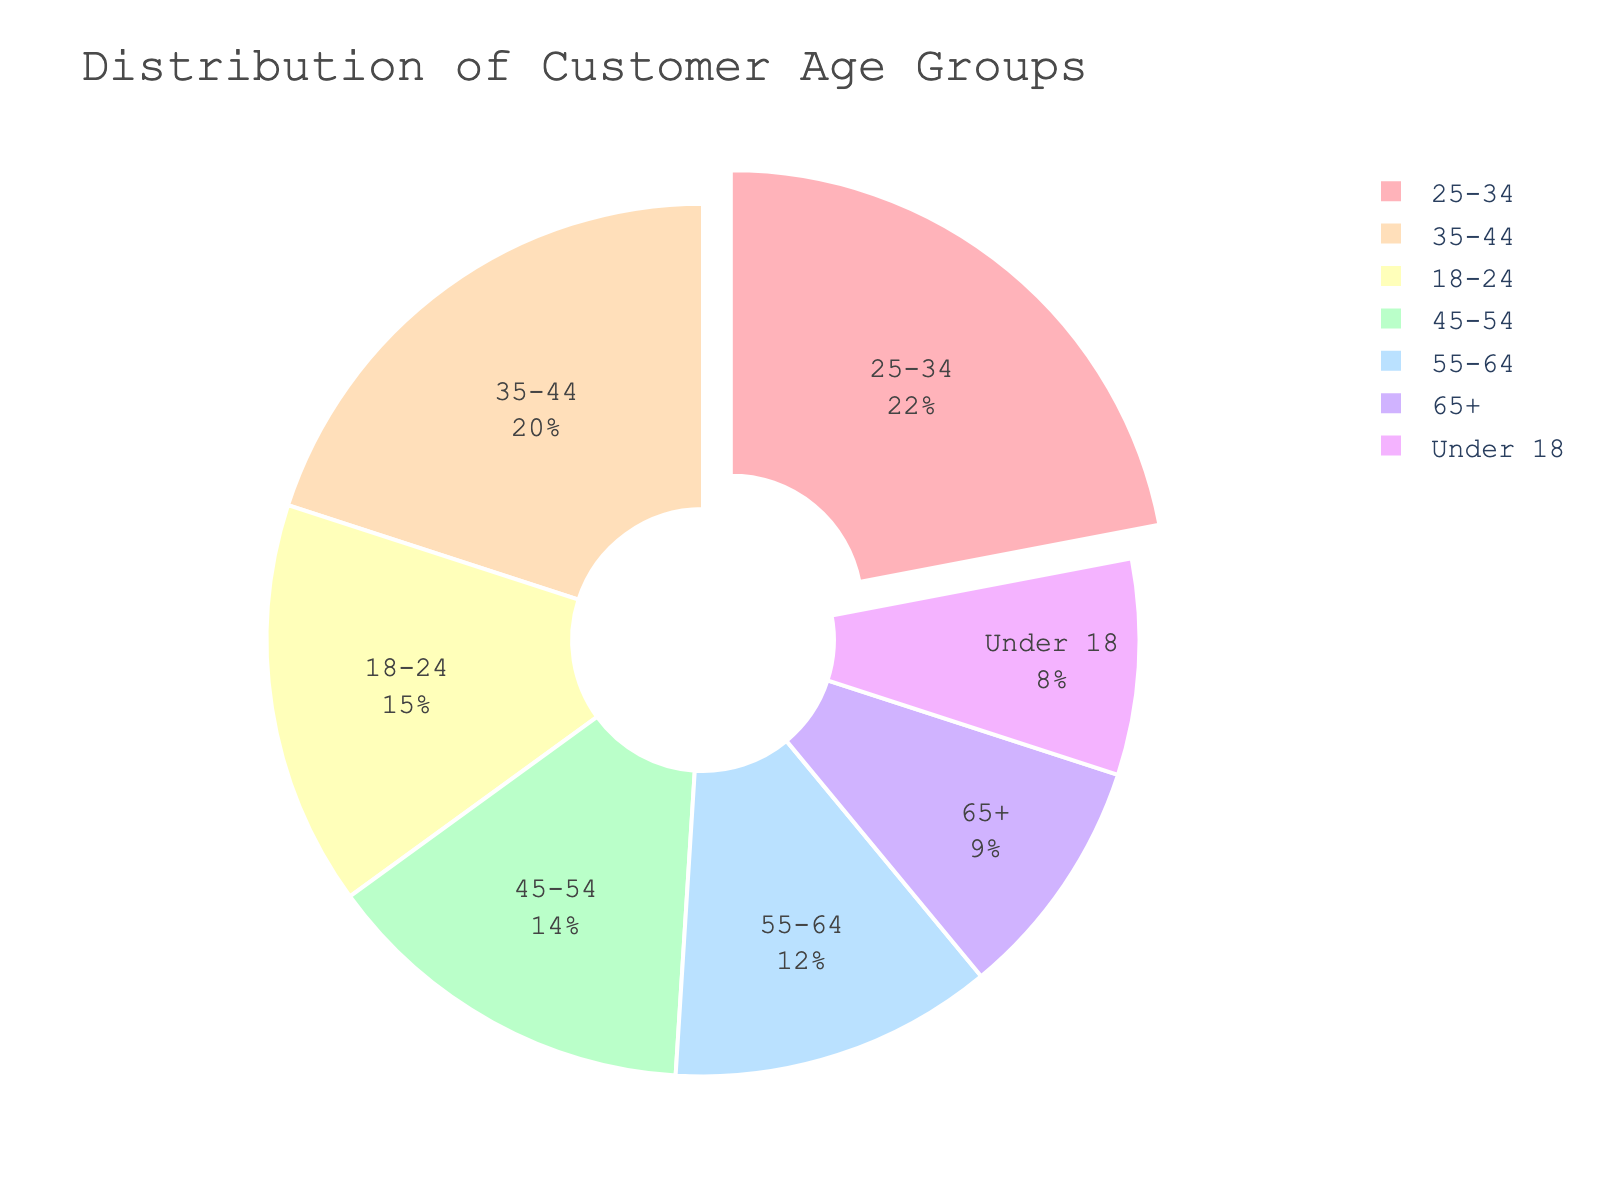What age group has the highest percentage of customers? The figure shows the percentage of each age group in a pie chart. The largest segment corresponds to the age group 25-34.
Answer: 25-34 How many age groups have less than 10% of customers? Examine the pie chart and count the segments representing less than 10%. Only one segment, "Under 18", satisfies this condition.
Answer: 1 Which age group has a higher percentage: 35-44 or 45-54? Compare the two segments on the pie chart. The segment for 35-44 is larger than that for 45-54.
Answer: 35-44 What is the combined percentage of customers aged 55-64 and 65+? Add the percentages of the two age groups: 12% for 55-64 and 9% for 65+. Calculation: 12 + 9 = 21.
Answer: 21 Which section of the pie chart is represented by the light blue color? Identify the light blue segment in the pie chart. It corresponds to the age group 65+.
Answer: 65+ How does the percentage of customers aged 18-24 compare to those aged 25-34? Observe both segments on the pie chart. The segment for 25-34 is larger than the segment for 18-24.
Answer: 25-34 is larger What percentage of customers are under 35? Sum the percentages of the groups "Under 18", "18-24", and "25-34": 8 + 15 + 22 = 45.
Answer: 45 Is there a significant difference between the percentages of customers aged 45-54 and 55-64? Compare the two percentages. They are 14% for 45-54 and 12% for 55-64. The difference is 2%.
Answer: No, not significant Which two age groups make up approximately one-third of the customer base? Look for groups whose percentages sum to around 33%. 22% for 25-34 and 12% for 55-64 sum to 34%, which is approximately one-third.
Answer: 25-34 and 55-64 What is the proportion of customers aged 25-44? Combine the percentages of 25-34 (22%) and 35-44 (20%) age groups: 22 + 20 = 42.
Answer: 42 